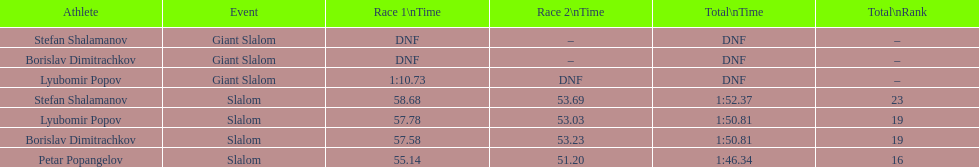Which competitor successfully finished the first race but couldn't complete the second one? Lyubomir Popov. I'm looking to parse the entire table for insights. Could you assist me with that? {'header': ['Athlete', 'Event', 'Race 1\\nTime', 'Race 2\\nTime', 'Total\\nTime', 'Total\\nRank'], 'rows': [['Stefan Shalamanov', 'Giant Slalom', 'DNF', '–', 'DNF', '–'], ['Borislav Dimitrachkov', 'Giant Slalom', 'DNF', '–', 'DNF', '–'], ['Lyubomir Popov', 'Giant Slalom', '1:10.73', 'DNF', 'DNF', '–'], ['Stefan Shalamanov', 'Slalom', '58.68', '53.69', '1:52.37', '23'], ['Lyubomir Popov', 'Slalom', '57.78', '53.03', '1:50.81', '19'], ['Borislav Dimitrachkov', 'Slalom', '57.58', '53.23', '1:50.81', '19'], ['Petar Popangelov', 'Slalom', '55.14', '51.20', '1:46.34', '16']]} 